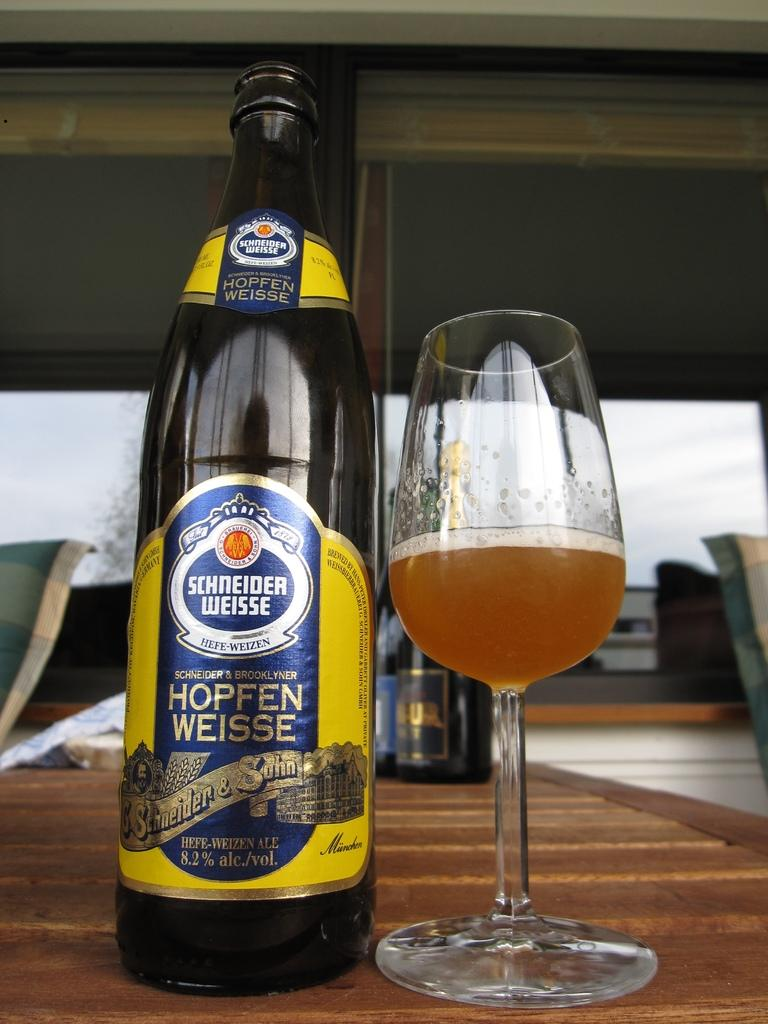<image>
Provide a brief description of the given image. A bottle of Schneider Weisse Hefe-Weizen is on a table next to a glass. 